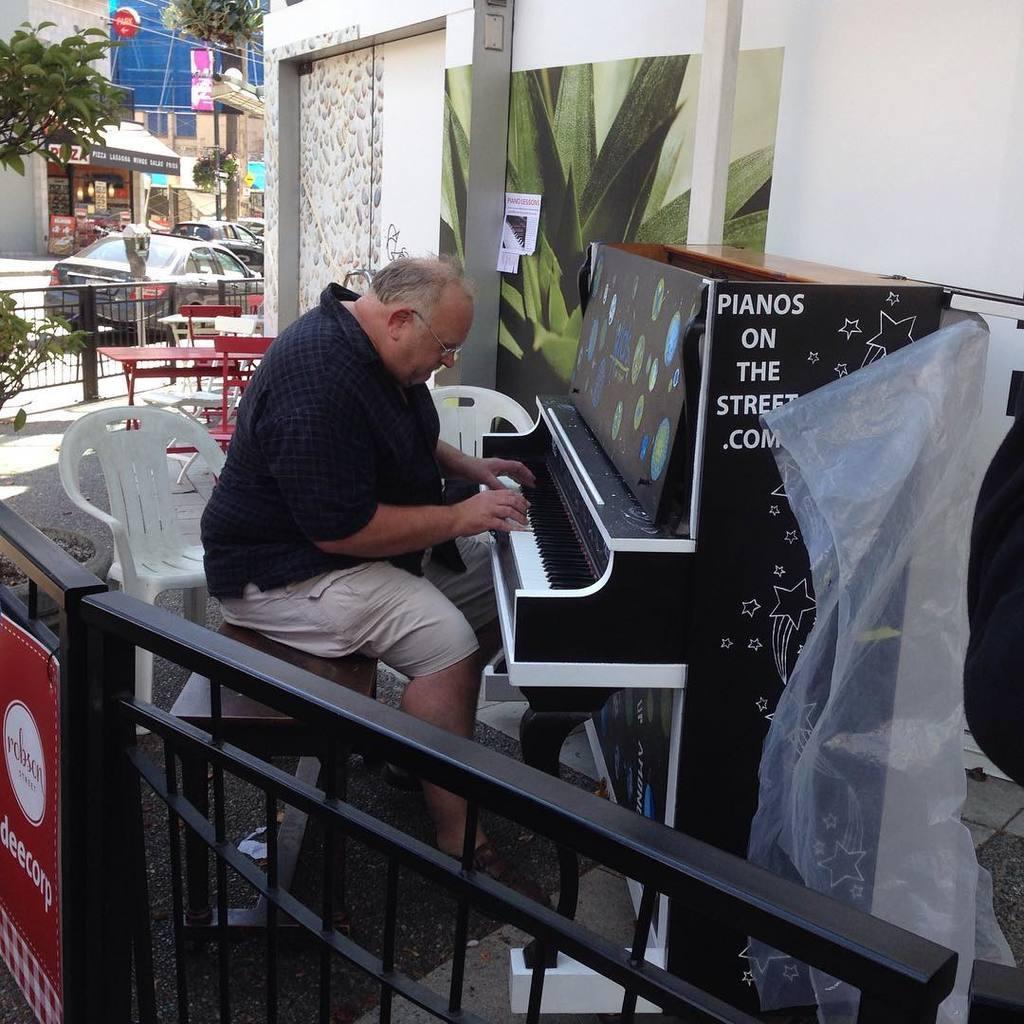Describe this image in one or two sentences. In this image there is a man sitting in a chair and playing a piano on the street ,and the back ground there is chairs, plants, tree, buildings, cars , name boards, iron rods. 